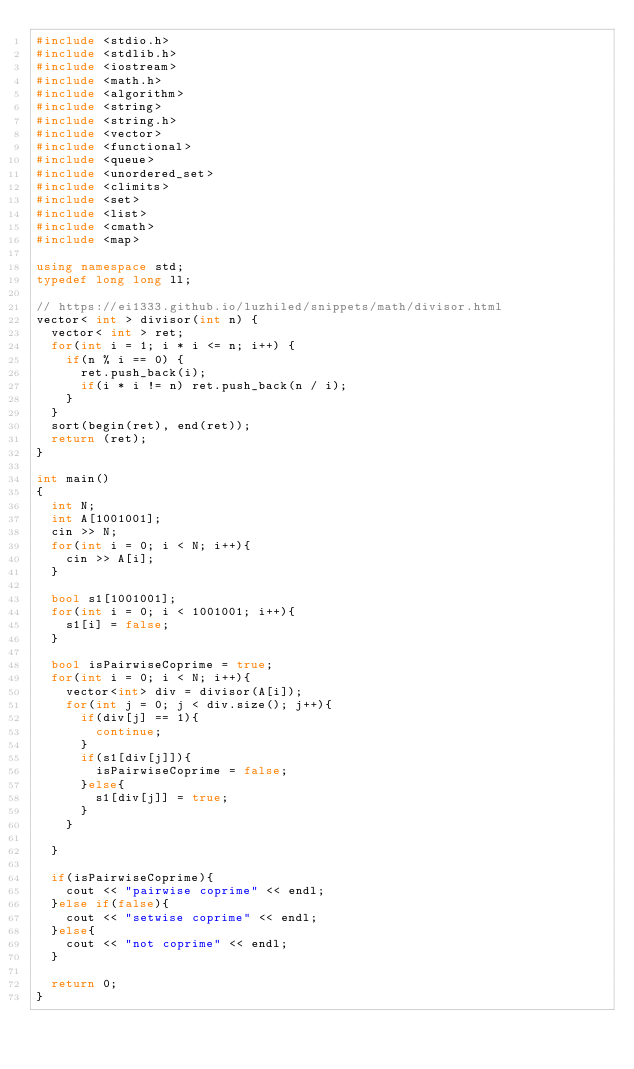Convert code to text. <code><loc_0><loc_0><loc_500><loc_500><_C++_>#include <stdio.h>
#include <stdlib.h>
#include <iostream>
#include <math.h>
#include <algorithm>
#include <string>
#include <string.h>
#include <vector>
#include <functional>
#include <queue>
#include <unordered_set>
#include <climits>
#include <set>
#include <list>
#include <cmath>
#include <map>

using namespace std;
typedef long long ll;

// https://ei1333.github.io/luzhiled/snippets/math/divisor.html
vector< int > divisor(int n) {
	vector< int > ret;
	for(int i = 1; i * i <= n; i++) {
		if(n % i == 0) {
			ret.push_back(i);
			if(i * i != n) ret.push_back(n / i);
		}
	}
	sort(begin(ret), end(ret));
	return (ret);
}

int main()
{
	int N;
	int A[1001001];
	cin >> N;
	for(int i = 0; i < N; i++){
		cin >> A[i];
	}
	
	bool s1[1001001];
	for(int i = 0; i < 1001001; i++){
		s1[i] = false;
	}
	
	bool isPairwiseCoprime = true;
	for(int i = 0; i < N; i++){
		vector<int> div = divisor(A[i]);
		for(int j = 0; j < div.size(); j++){
			if(div[j] == 1){
				continue;
			}
			if(s1[div[j]]){
				isPairwiseCoprime = false;
			}else{
				s1[div[j]] = true;
			}
		}
		
	}
	
	if(isPairwiseCoprime){
		cout << "pairwise coprime" << endl;
	}else if(false){
		cout << "setwise coprime" << endl;
	}else{
		cout << "not coprime" << endl;
	}
	
	return 0;
}
</code> 